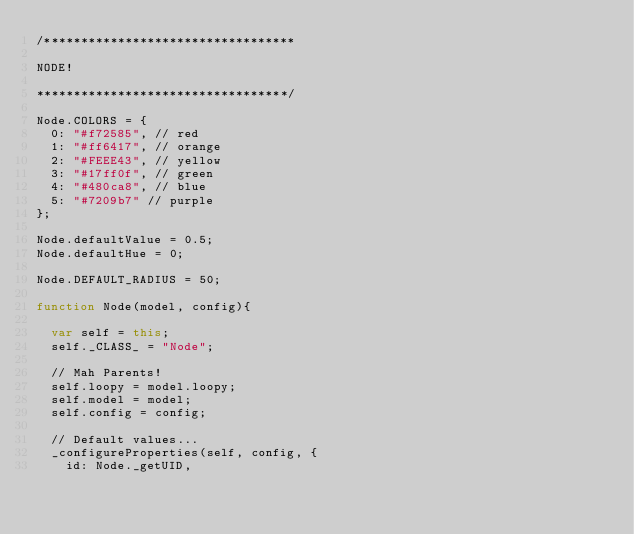Convert code to text. <code><loc_0><loc_0><loc_500><loc_500><_JavaScript_>/**********************************

NODE!

**********************************/

Node.COLORS = {
	0: "#f72585", // red
	1: "#ff6417", // orange
	2: "#FEEE43", // yellow
	3: "#17ff0f", // green
	4: "#480ca8", // blue
	5: "#7209b7" // purple
};

Node.defaultValue = 0.5;
Node.defaultHue = 0;

Node.DEFAULT_RADIUS = 50;

function Node(model, config){

	var self = this;
	self._CLASS_ = "Node";

	// Mah Parents!
	self.loopy = model.loopy;
	self.model = model;
	self.config = config;

	// Default values...
	_configureProperties(self, config, {
		id: Node._getUID,</code> 